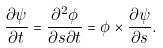Convert formula to latex. <formula><loc_0><loc_0><loc_500><loc_500>\frac { \partial \psi } { \partial t } = \frac { \partial ^ { 2 } \phi } { \partial s \partial t } = \phi \times \frac { \partial \psi } { \partial s } .</formula> 